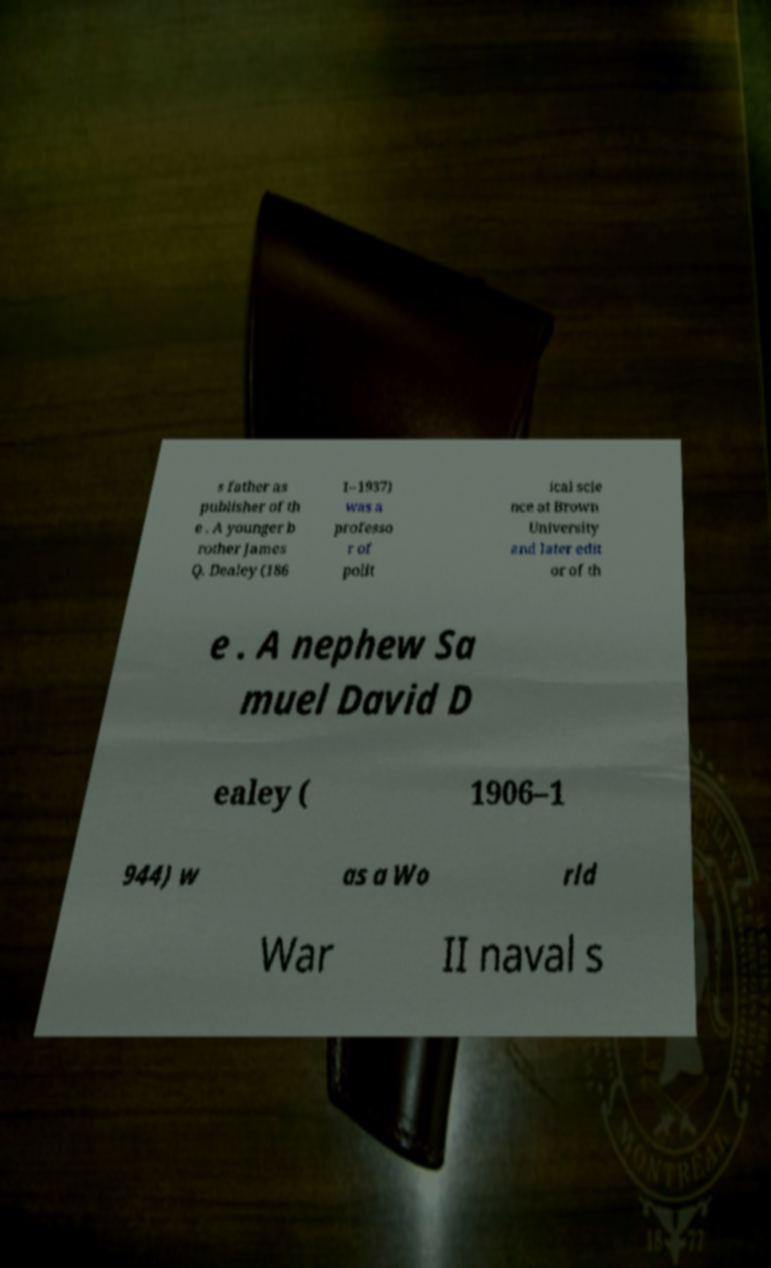Please identify and transcribe the text found in this image. s father as publisher of th e . A younger b rother James Q. Dealey (186 1–1937) was a professo r of polit ical scie nce at Brown University and later edit or of th e . A nephew Sa muel David D ealey ( 1906–1 944) w as a Wo rld War II naval s 